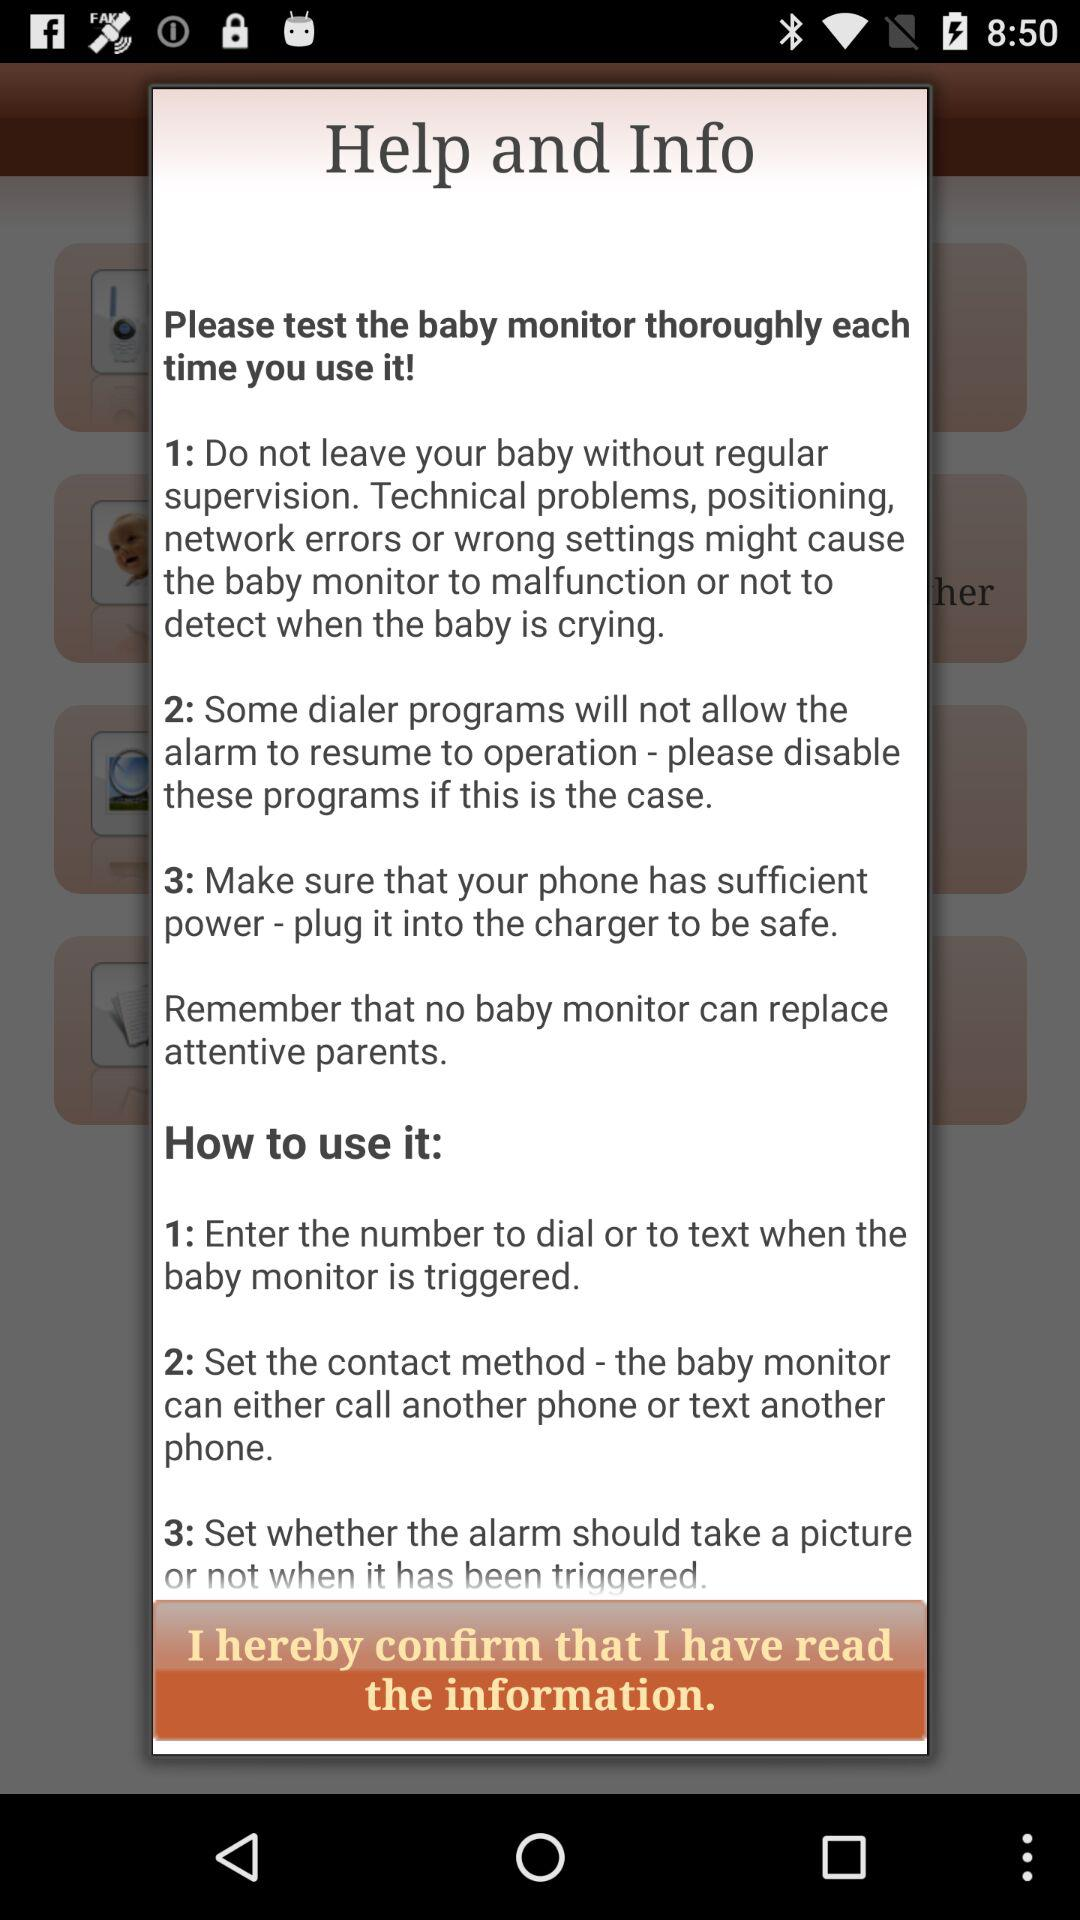How to use the baby monitor? The steps to use the baby monitor is "Enter the number to dial or to text when the baby monitor is triggered", "Set the contact method - the baby monitor can either call another phone or text another phone" and "Set whether the alarm should take a picture or not when it has been triggered". 